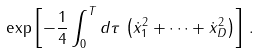Convert formula to latex. <formula><loc_0><loc_0><loc_500><loc_500>\exp \left [ - \frac { 1 } { 4 } \int _ { 0 } ^ { T } d \tau \, \left ( \dot { x } _ { 1 } ^ { 2 } + \dots + \dot { x } _ { D } ^ { 2 } \right ) \right ] \, .</formula> 